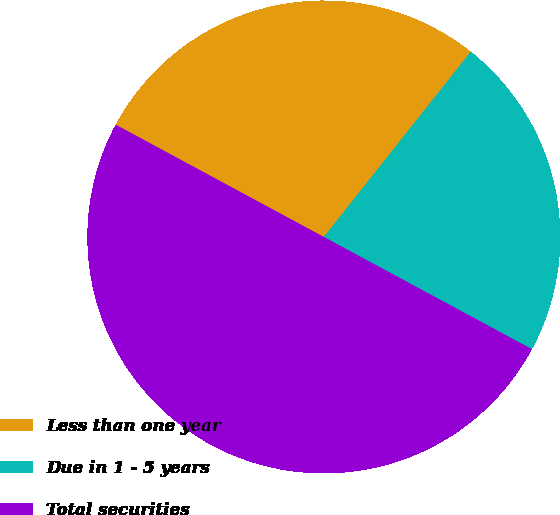Convert chart to OTSL. <chart><loc_0><loc_0><loc_500><loc_500><pie_chart><fcel>Less than one year<fcel>Due in 1 - 5 years<fcel>Total securities<nl><fcel>27.8%<fcel>22.2%<fcel>50.0%<nl></chart> 